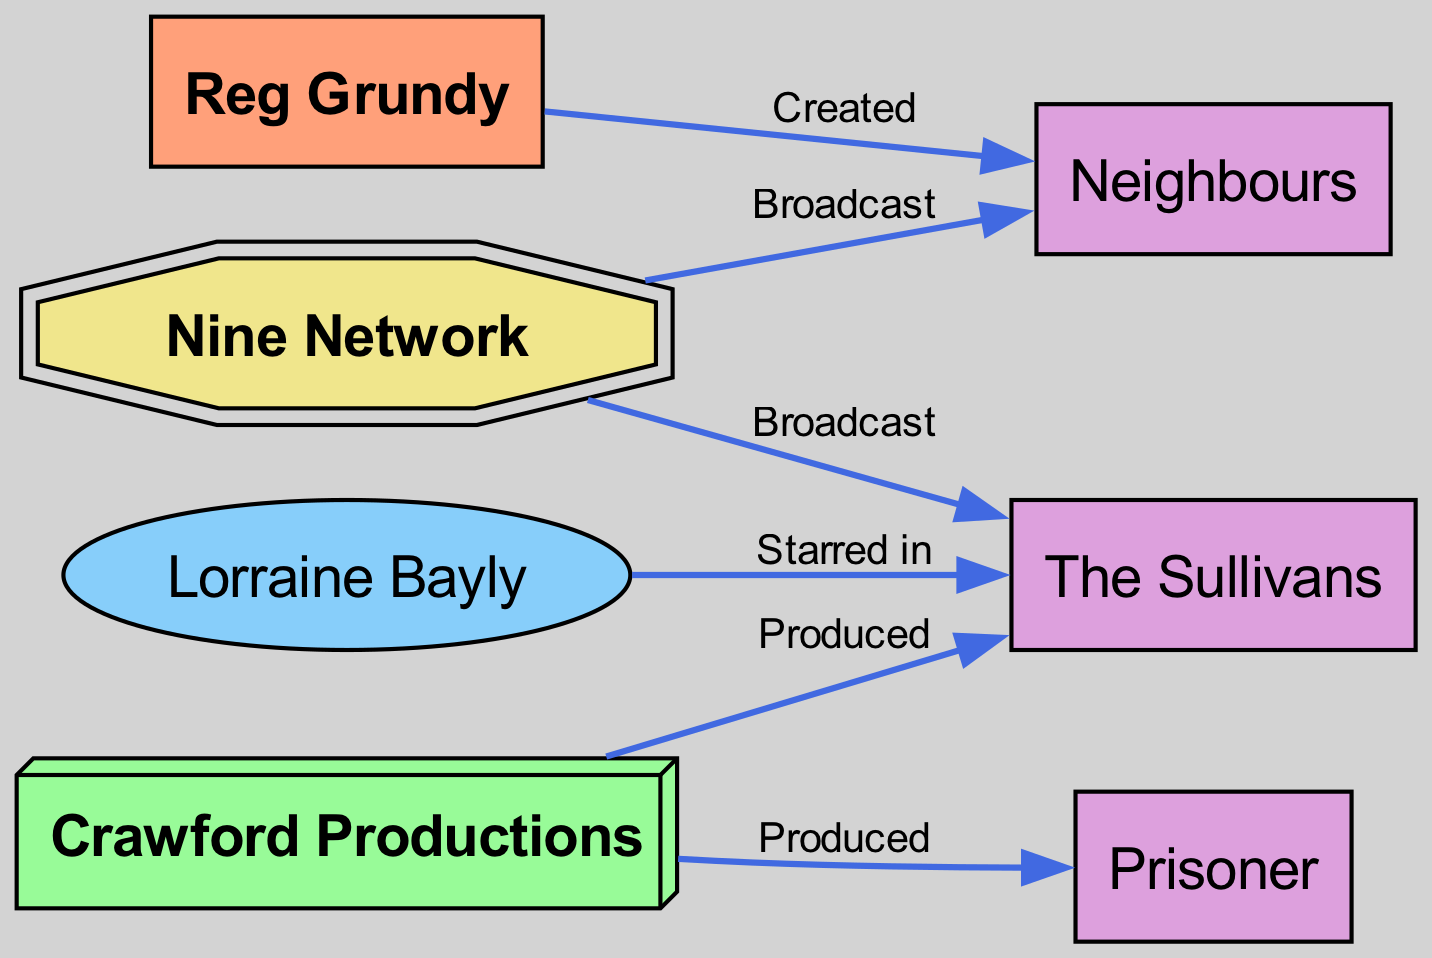What is the role of Reg Grundy in the diagram? Reg Grundy is listed as a node in the diagram with the role of "Producer". This information can be directly found in the node details for Reg Grundy.
Answer: Producer Which TV show did Lorraine Bayly star in? The diagram indicates that Lorraine Bayly is connected to "The Sullivans" with the relationship of "Starred in". Thus, the TV show she starred in is "The Sullivans".
Answer: The Sullivans How many TV shows are represented in the diagram? The diagram contains three TV shows: "Neighbours", "Prisoner", and "The Sullivans". To determine the count, one can tally the nodes of the type "TV Show".
Answer: 3 What relationship does Crawford Productions have with Prisoner? The diagram shows an edge connecting Crawford Productions to "Prisoner" with the relationship labeled as "Produced". This indicates that Crawford Productions produced the show "Prisoner".
Answer: Produced Which network broadcasts Neighbours? The diagram indicates that the Nine Network broadcasts "Neighbours", as shown by the direct connection with the relationship labeled "Broadcast".
Answer: Nine Network Who created Neighbours? According to the diagram, Reg Grundy is the entity that created "Neighbours", as per the directed edge labeled "Created" pointing from Reg Grundy to "Neighbours".
Answer: Reg Grundy How many edges connect to the Nine Network? The Nine Network has two directed edges connecting it to "Neighbours" and "The Sullivans" as indicated in the diagram. By counting these specific connections, we can conclude the total.
Answer: 2 What type of entity is Crawford Productions? In the diagram, Crawford Productions is categorized as a "Production Company", which is explicitly stated in its node details.
Answer: Production Company Which TV show is not produced by Crawford Productions? According to the diagram, "Neighbours" is created by Reg Grundy and not connected to Crawford Productions in the context of production, making it the answer to this question.
Answer: Neighbours 